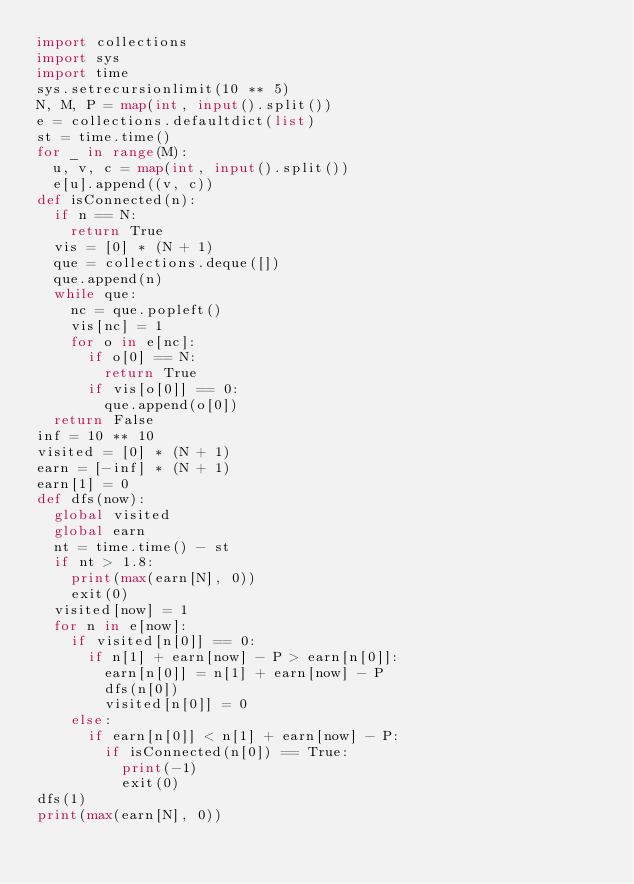<code> <loc_0><loc_0><loc_500><loc_500><_Python_>import collections
import sys
import time
sys.setrecursionlimit(10 ** 5)
N, M, P = map(int, input().split())
e = collections.defaultdict(list)
st = time.time()
for _ in range(M):
  u, v, c = map(int, input().split())
  e[u].append((v, c))
def isConnected(n):
  if n == N:
    return True
  vis = [0] * (N + 1)
  que = collections.deque([])
  que.append(n)
  while que:
    nc = que.popleft()
    vis[nc] = 1
    for o in e[nc]:
      if o[0] == N:
        return True
      if vis[o[0]] == 0:
        que.append(o[0])
  return False
inf = 10 ** 10
visited = [0] * (N + 1)
earn = [-inf] * (N + 1)
earn[1] = 0
def dfs(now):
  global visited
  global earn
  nt = time.time() - st
  if nt > 1.8:
    print(max(earn[N], 0))
    exit(0)
  visited[now] = 1
  for n in e[now]:
    if visited[n[0]] == 0:
      if n[1] + earn[now] - P > earn[n[0]]:
        earn[n[0]] = n[1] + earn[now] - P
        dfs(n[0])
        visited[n[0]] = 0
    else:
      if earn[n[0]] < n[1] + earn[now] - P:
        if isConnected(n[0]) == True:
          print(-1)
          exit(0)
dfs(1)
print(max(earn[N], 0))


</code> 